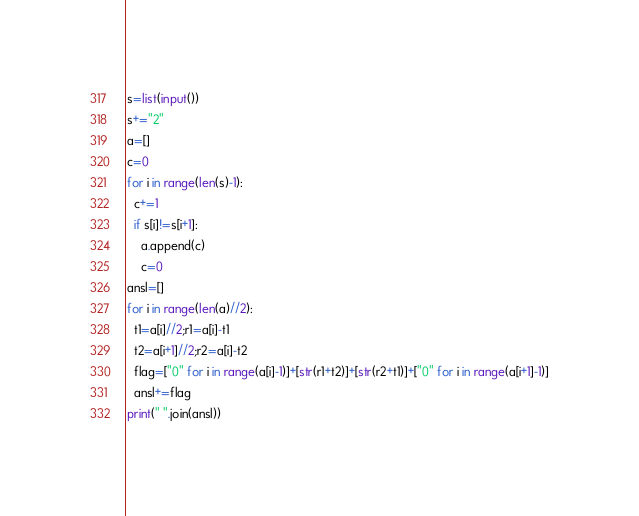<code> <loc_0><loc_0><loc_500><loc_500><_Python_>s=list(input())
s+="2"
a=[]
c=0
for i in range(len(s)-1):
  c+=1
  if s[i]!=s[i+1]:
    a.append(c)
    c=0
ansl=[]
for i in range(len(a)//2):
  t1=a[i]//2;r1=a[i]-t1
  t2=a[i+1]//2;r2=a[i]-t2
  flag=["0" for i in range(a[i]-1)]+[str(r1+t2)]+[str(r2+t1)]+["0" for i in range(a[i+1]-1)]
  ansl+=flag
print(" ".join(ansl))</code> 